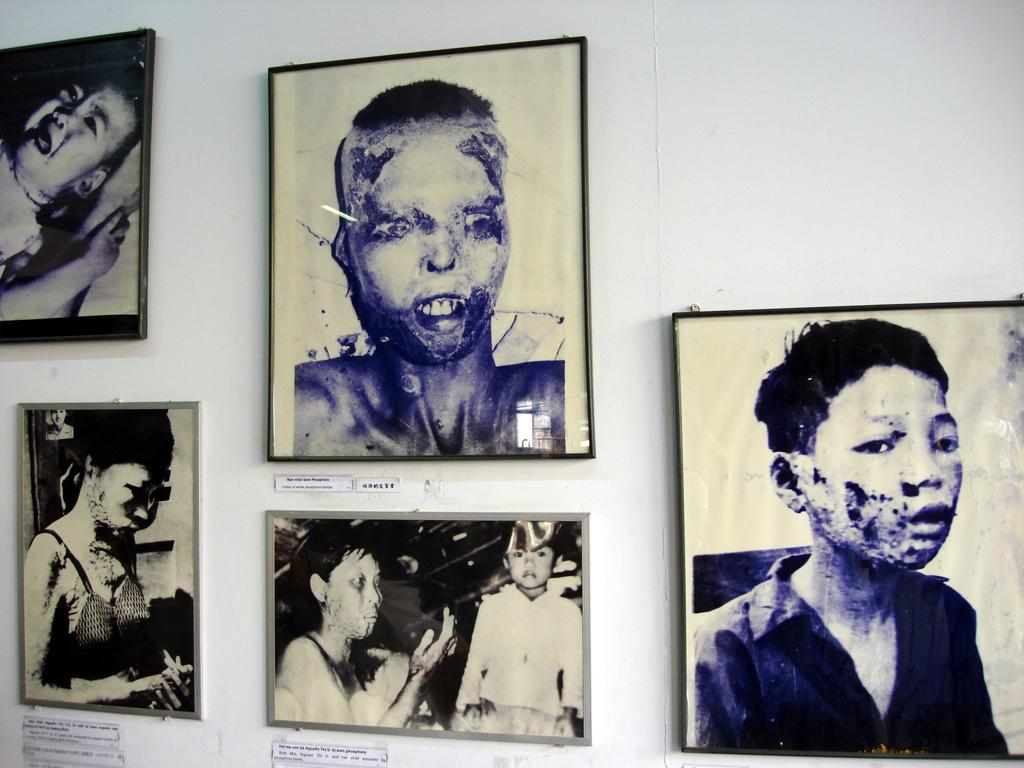What is hanging on the wall in the image? There are photo frames of people on the wall in the image. Can you describe the content of the photo frames? The photo frames contain images of people. What type of zipper can be seen on the wall in the image? There is no zipper present on the wall in the image; it features photo frames of people. Is there a balloon floating in the room in the image? There is no mention of a balloon in the image, which only shows photo frames on the wall. 